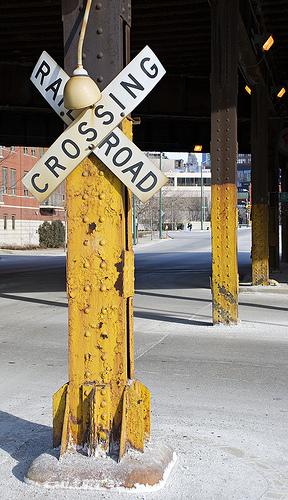Are there people in the photo?
Be succinct. No. How many trains pass by this railroad crossing?
Keep it brief. 1. What does the sign say?
Quick response, please. Railroad crossing. 